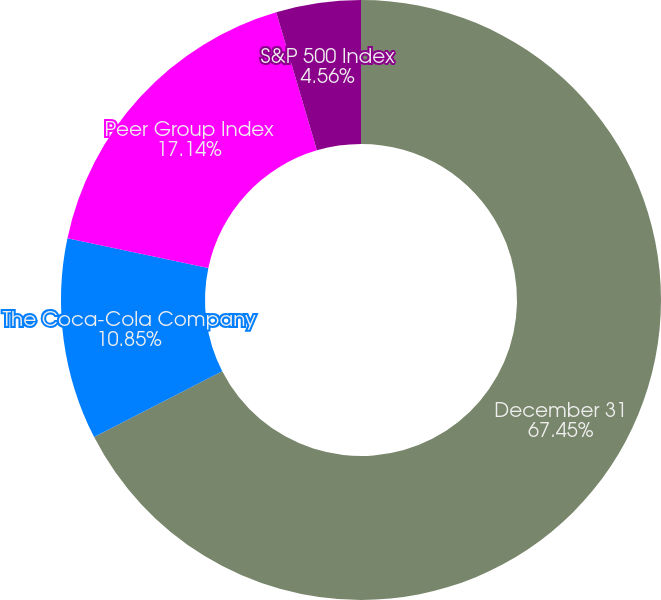<chart> <loc_0><loc_0><loc_500><loc_500><pie_chart><fcel>December 31<fcel>The Coca-Cola Company<fcel>Peer Group Index<fcel>S&P 500 Index<nl><fcel>67.45%<fcel>10.85%<fcel>17.14%<fcel>4.56%<nl></chart> 